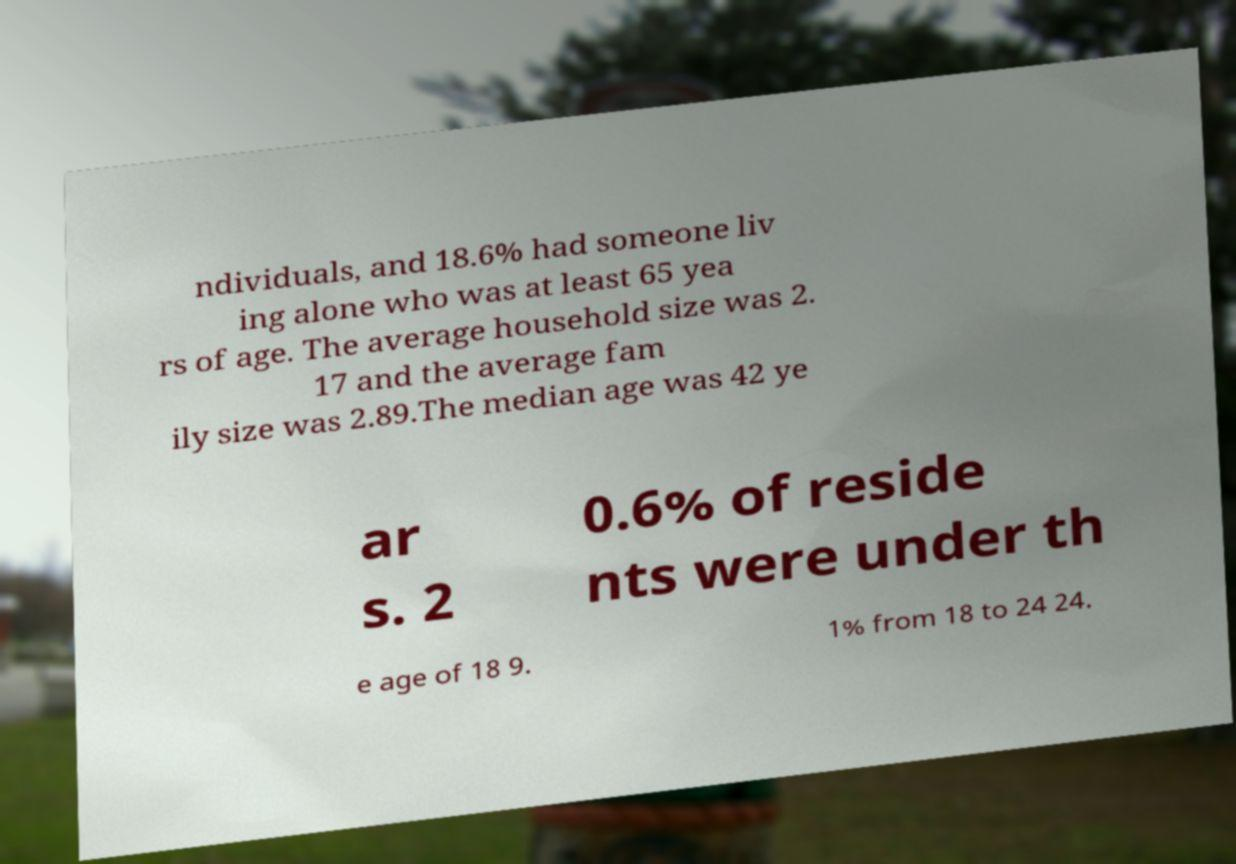What messages or text are displayed in this image? I need them in a readable, typed format. ndividuals, and 18.6% had someone liv ing alone who was at least 65 yea rs of age. The average household size was 2. 17 and the average fam ily size was 2.89.The median age was 42 ye ar s. 2 0.6% of reside nts were under th e age of 18 9. 1% from 18 to 24 24. 